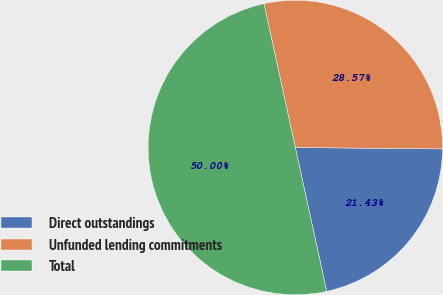<chart> <loc_0><loc_0><loc_500><loc_500><pie_chart><fcel>Direct outstandings<fcel>Unfunded lending commitments<fcel>Total<nl><fcel>21.43%<fcel>28.57%<fcel>50.0%<nl></chart> 